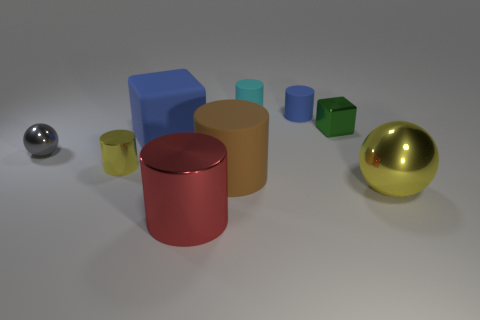Subtract all metallic cylinders. How many cylinders are left? 3 Add 1 small cyan matte cylinders. How many objects exist? 10 Subtract 2 blocks. How many blocks are left? 0 Subtract all cubes. How many objects are left? 7 Subtract all yellow spheres. How many spheres are left? 1 Subtract all small green shiny cylinders. Subtract all tiny yellow metal things. How many objects are left? 8 Add 7 large red metal cylinders. How many large red metal cylinders are left? 8 Add 6 purple balls. How many purple balls exist? 6 Subtract 1 red cylinders. How many objects are left? 8 Subtract all red cubes. Subtract all brown cylinders. How many cubes are left? 2 